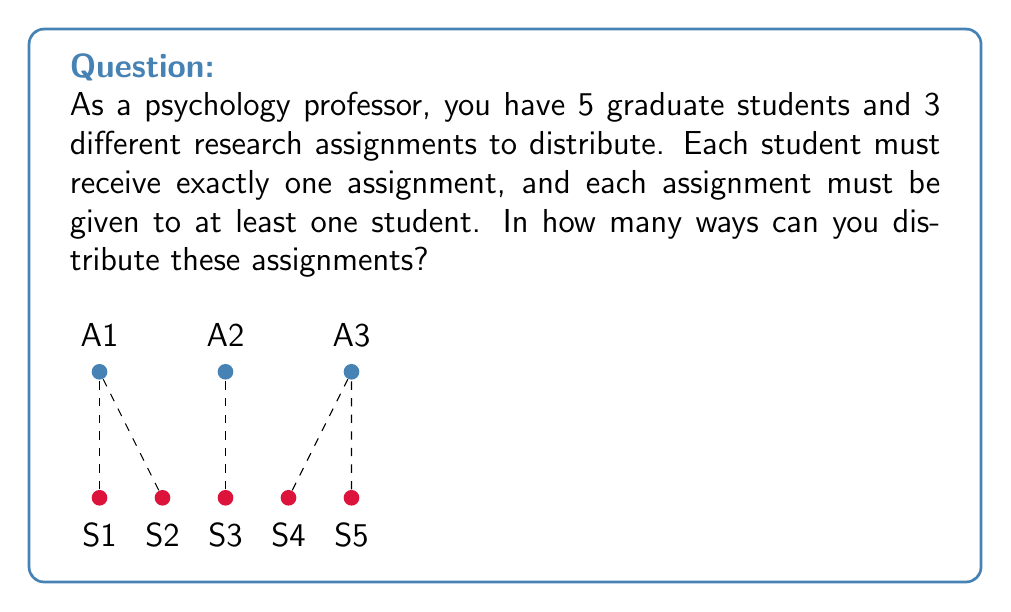Solve this math problem. Let's approach this step-by-step using the concept of stirling numbers of the second kind and the multiplication principle.

1) This problem is equivalent to partitioning 5 students into 3 non-empty subsets (each subset corresponding to an assignment).

2) The number of ways to partition n distinct objects into k non-empty subsets is given by the Stirling number of the second kind, denoted as $\stirling{n}{k}$.

3) In this case, we need $\stirling{5}{3}$.

4) The formula for $\stirling{n}{k}$ is:

   $$\stirling{n}{k} = \frac{1}{k!}\sum_{i=0}^k (-1)^i \binom{k}{i}(k-i)^n$$

5) Plugging in our values:

   $$\stirling{5}{3} = \frac{1}{3!}\sum_{i=0}^3 (-1)^i \binom{3}{i}(3-i)^5$$

6) Expanding this:
   
   $$\stirling{5}{3} = \frac{1}{6}[(1)(3^5) + (-3)(2^5) + (3)(1^5) + (-1)(0^5)]$$

7) Calculating:
   
   $$\stirling{5}{3} = \frac{1}{6}[243 - 96 + 3 + 0] = \frac{150}{6} = 25$$

8) Therefore, there are 25 ways to distribute the assignments.
Answer: 25 